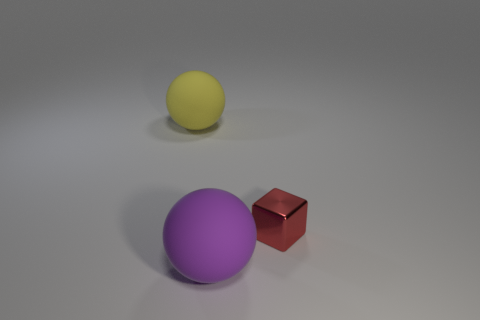Add 3 yellow spheres. How many objects exist? 6 Subtract all yellow balls. How many balls are left? 1 Subtract 0 purple cylinders. How many objects are left? 3 Subtract all spheres. How many objects are left? 1 Subtract 1 spheres. How many spheres are left? 1 Subtract all brown blocks. Subtract all blue balls. How many blocks are left? 1 Subtract all purple matte objects. Subtract all purple rubber spheres. How many objects are left? 1 Add 2 yellow objects. How many yellow objects are left? 3 Add 2 red blocks. How many red blocks exist? 3 